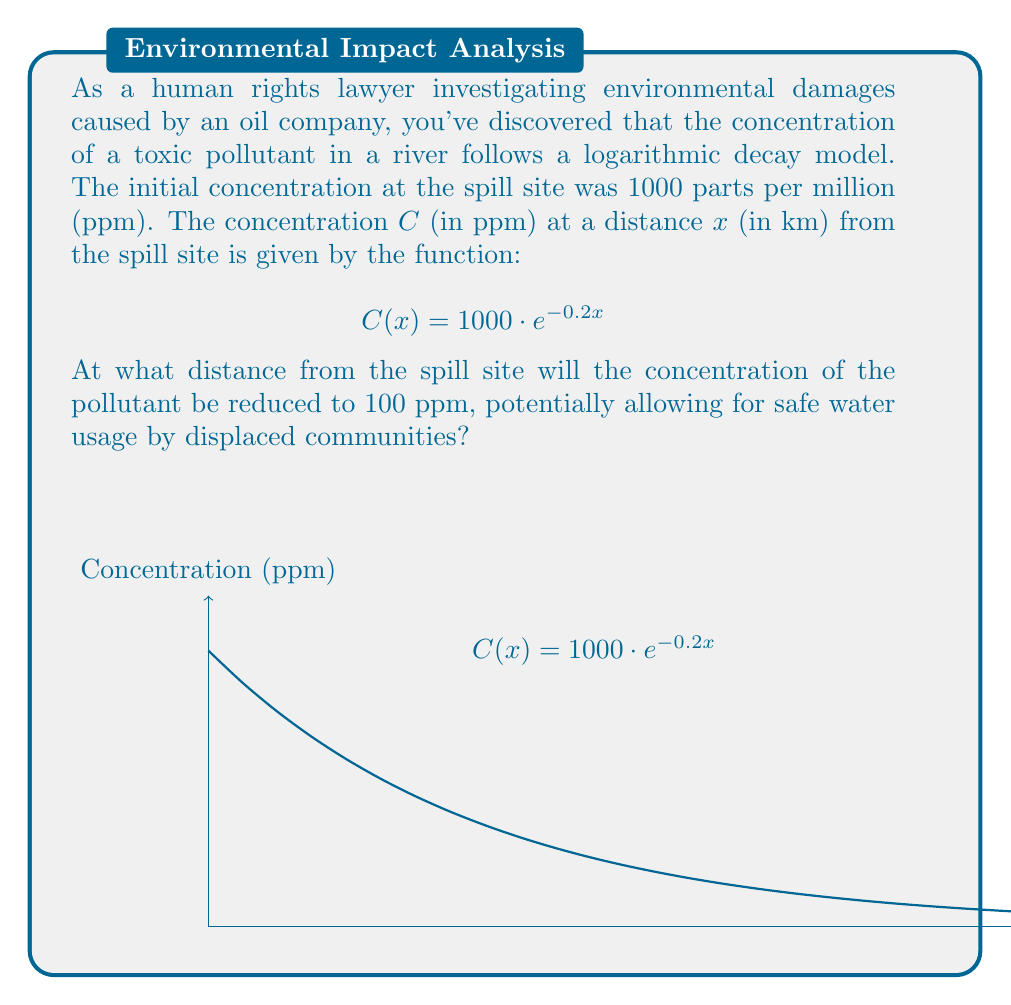Solve this math problem. To solve this problem, we need to find the value of $x$ when $C(x) = 100$. Let's approach this step-by-step:

1) We start with the equation:
   $$C(x) = 1000 \cdot e^{-0.2x}$$

2) We want to find $x$ when $C(x) = 100$, so we set up the equation:
   $$100 = 1000 \cdot e^{-0.2x}$$

3) Divide both sides by 1000:
   $$0.1 = e^{-0.2x}$$

4) Take the natural logarithm of both sides:
   $$\ln(0.1) = \ln(e^{-0.2x})$$

5) Simplify the right side using the properties of logarithms:
   $$\ln(0.1) = -0.2x$$

6) Solve for $x$:
   $$x = -\frac{\ln(0.1)}{0.2}$$

7) Calculate the value (you can use a calculator for this):
   $$x = -\frac{-2.30259}{0.2} \approx 11.51295$$

Therefore, the concentration will be reduced to 100 ppm at approximately 11.51 km from the spill site.
Answer: 11.51 km 